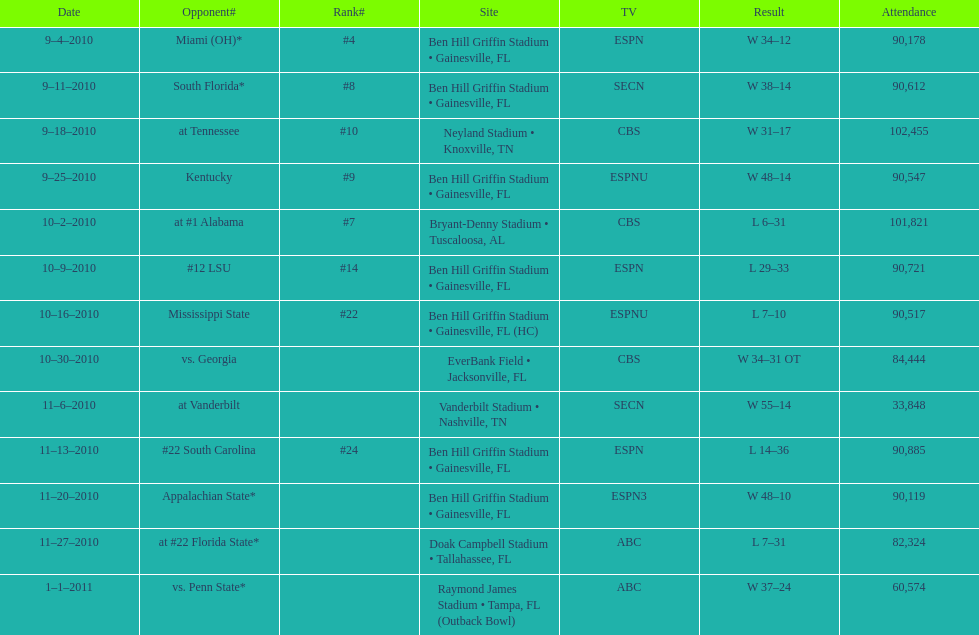During the 2010 season, for how many successive weeks did the gators remain victorious until they encountered their initial defeat? 4. 